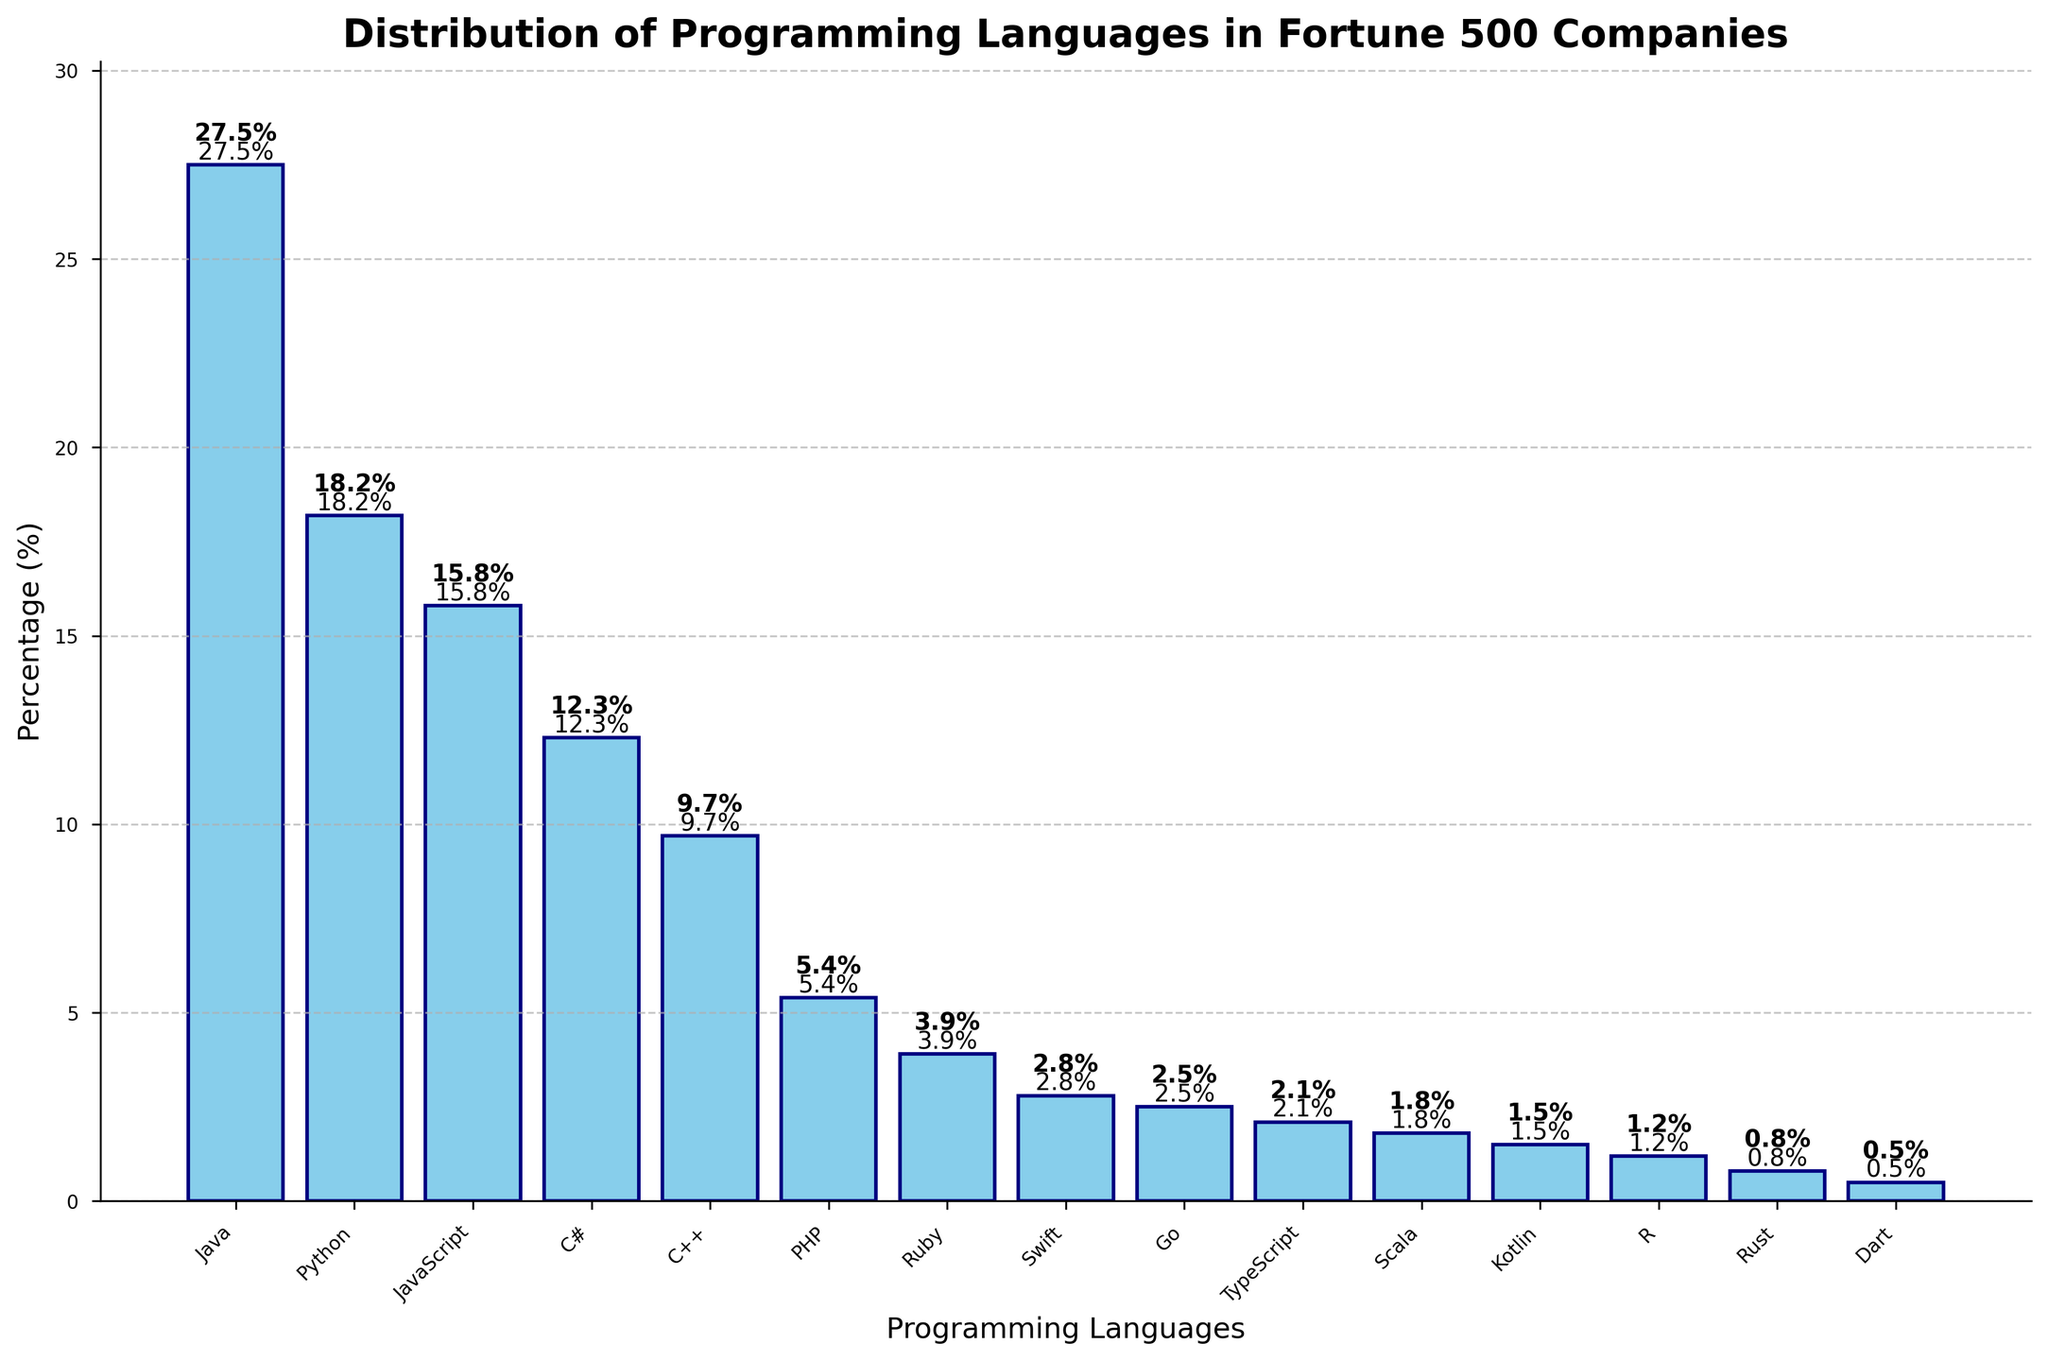What are the top three programming languages by percentage? To determine the top three programming languages, look at the heights of the bars and the percentages. The highest bars are for Java (27.5%), Python (18.2%), and JavaScript (15.8%).
Answer: Java, Python, JavaScript What is the combined percentage of C++ and PHP? Add the percentages of C++ (9.7%) and PHP (5.4%) together: 9.7% + 5.4% = 15.1%.
Answer: 15.1% Which language is used less frequently, Swift or Go? Compare the heights of the bars for Swift and Go. Swift has a percentage of 2.8% and Go has 2.5%. Since 2.5% is less than 2.8%, Go is used less frequently.
Answer: Go How much more is Java used compared to Rust? Subtract the percentage of Rust from the percentage of Java: 27.5% - 0.8% = 26.7%.
Answer: 26.7% What is the average percentage usage of Ruby, Swift, and Go? Add the percentages of Ruby (3.9%), Swift (2.8%), and Go (2.5%) and divide by 3: (3.9% + 2.8% + 2.5%) / 3 = 9.2% / 3 = 3.07%.
Answer: 3.07% Which language has a percentage just under 10%? Find the bar with a percentage less than but closest to 10%. C++ has a percentage of 9.7%, which is just under 10%.
Answer: C++ What is the percentage difference between JavaScript and C#? Subtract the percentage of C# from JavaScript: 15.8% - 12.3% = 3.5%.
Answer: 3.5% What is the total percentage usage of the top five programming languages? Sum the percentages of the top five languages: Java (27.5%), Python (18.2%), JavaScript (15.8%), C# (12.3%), C++ (9.7%): 27.5% + 18.2% + 15.8% + 12.3% + 9.7% = 83.5%.
Answer: 83.5% What is the median percentage of all the programming languages listed? To find the median, arrange the percentages in order and find the middle value. The ordered percentages are: 0.5, 0.8, 1.2, 1.5, 1.8, 2.1, 2.5, 2.8, 3.9, 5.4, 9.7, 12.3, 15.8, 18.2, 27.5. The middle value (8th value) is 2.8.
Answer: 2.8% Which programming languages have percentages lower than the average percentage of all languages in the chart? First, calculate the average percentage of all languages: sum all percentages and divide by number of languages. Sum is 100.0%, and there are 15 languages: 100% / 15 = 6.67%. Languages with percentages below 6.67% are PHP, Ruby, Swift, Go, TypeScript, Scala, Kotlin, R, Rust, and Dart.
Answer: PHP, Ruby, Swift, Go, TypeScript, Scala, Kotlin, R, Rust, Dart 